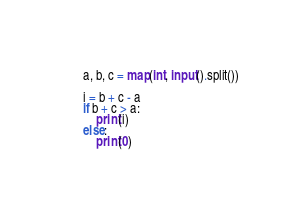<code> <loc_0><loc_0><loc_500><loc_500><_Python_>a, b, c = map(int, input().split())

i = b + c - a
if b + c > a:
    print(i)
else:
    print(0)</code> 